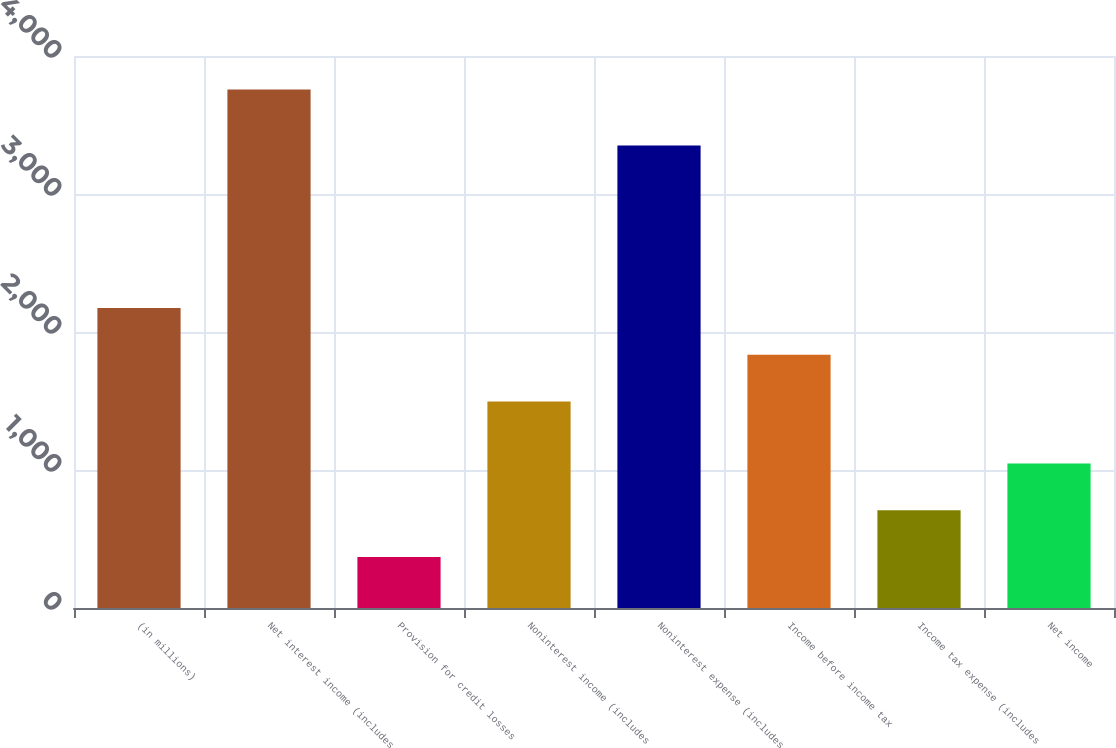Convert chart. <chart><loc_0><loc_0><loc_500><loc_500><bar_chart><fcel>(in millions)<fcel>Net interest income (includes<fcel>Provision for credit losses<fcel>Noninterest income (includes<fcel>Noninterest expense (includes<fcel>Income before income tax<fcel>Income tax expense (includes<fcel>Net income<nl><fcel>2174.8<fcel>3758<fcel>369<fcel>1497<fcel>3352<fcel>1835.9<fcel>707.9<fcel>1046.8<nl></chart> 